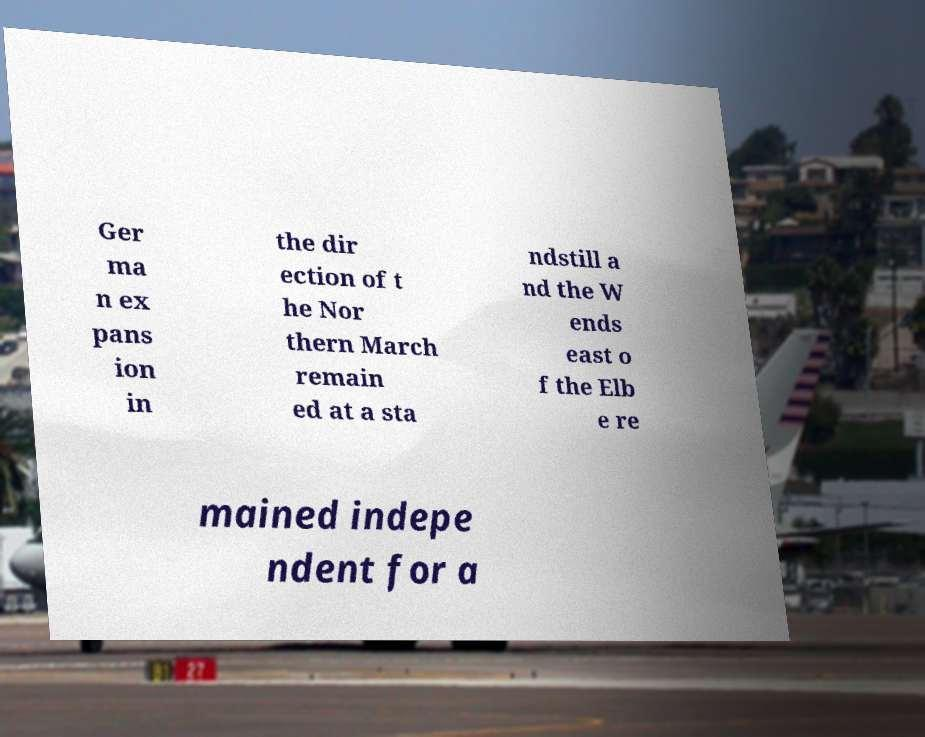Please identify and transcribe the text found in this image. Ger ma n ex pans ion in the dir ection of t he Nor thern March remain ed at a sta ndstill a nd the W ends east o f the Elb e re mained indepe ndent for a 